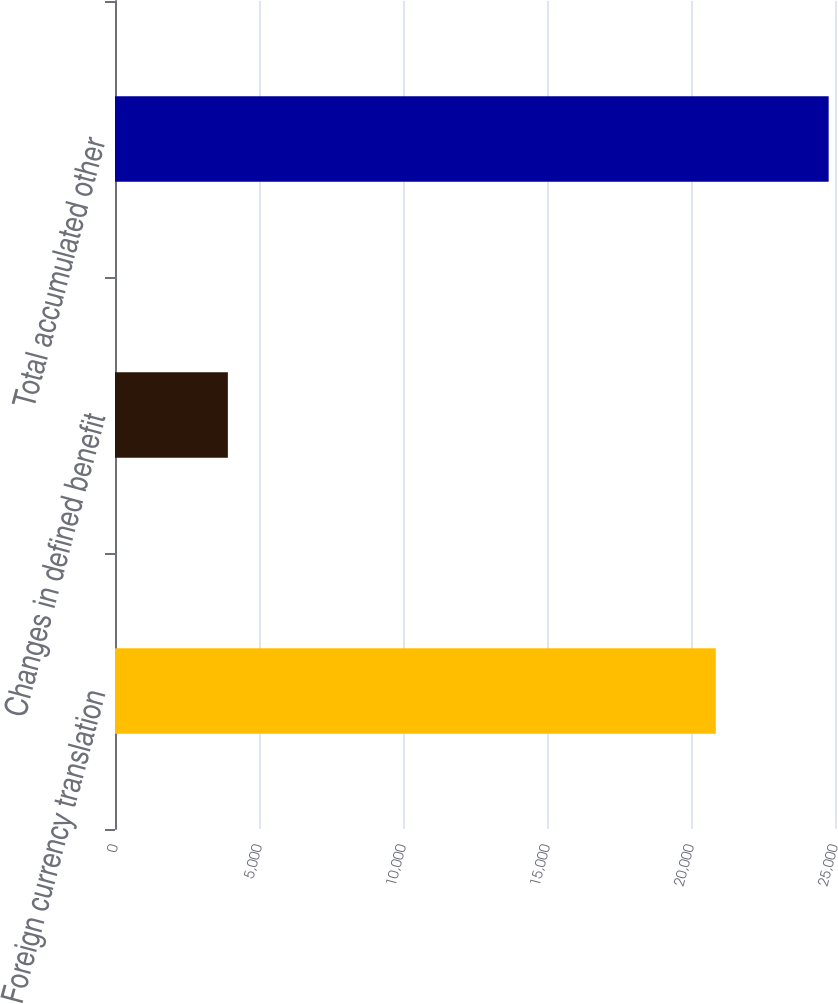<chart> <loc_0><loc_0><loc_500><loc_500><bar_chart><fcel>Foreign currency translation<fcel>Changes in defined benefit<fcel>Total accumulated other<nl><fcel>20861<fcel>3919<fcel>24780<nl></chart> 